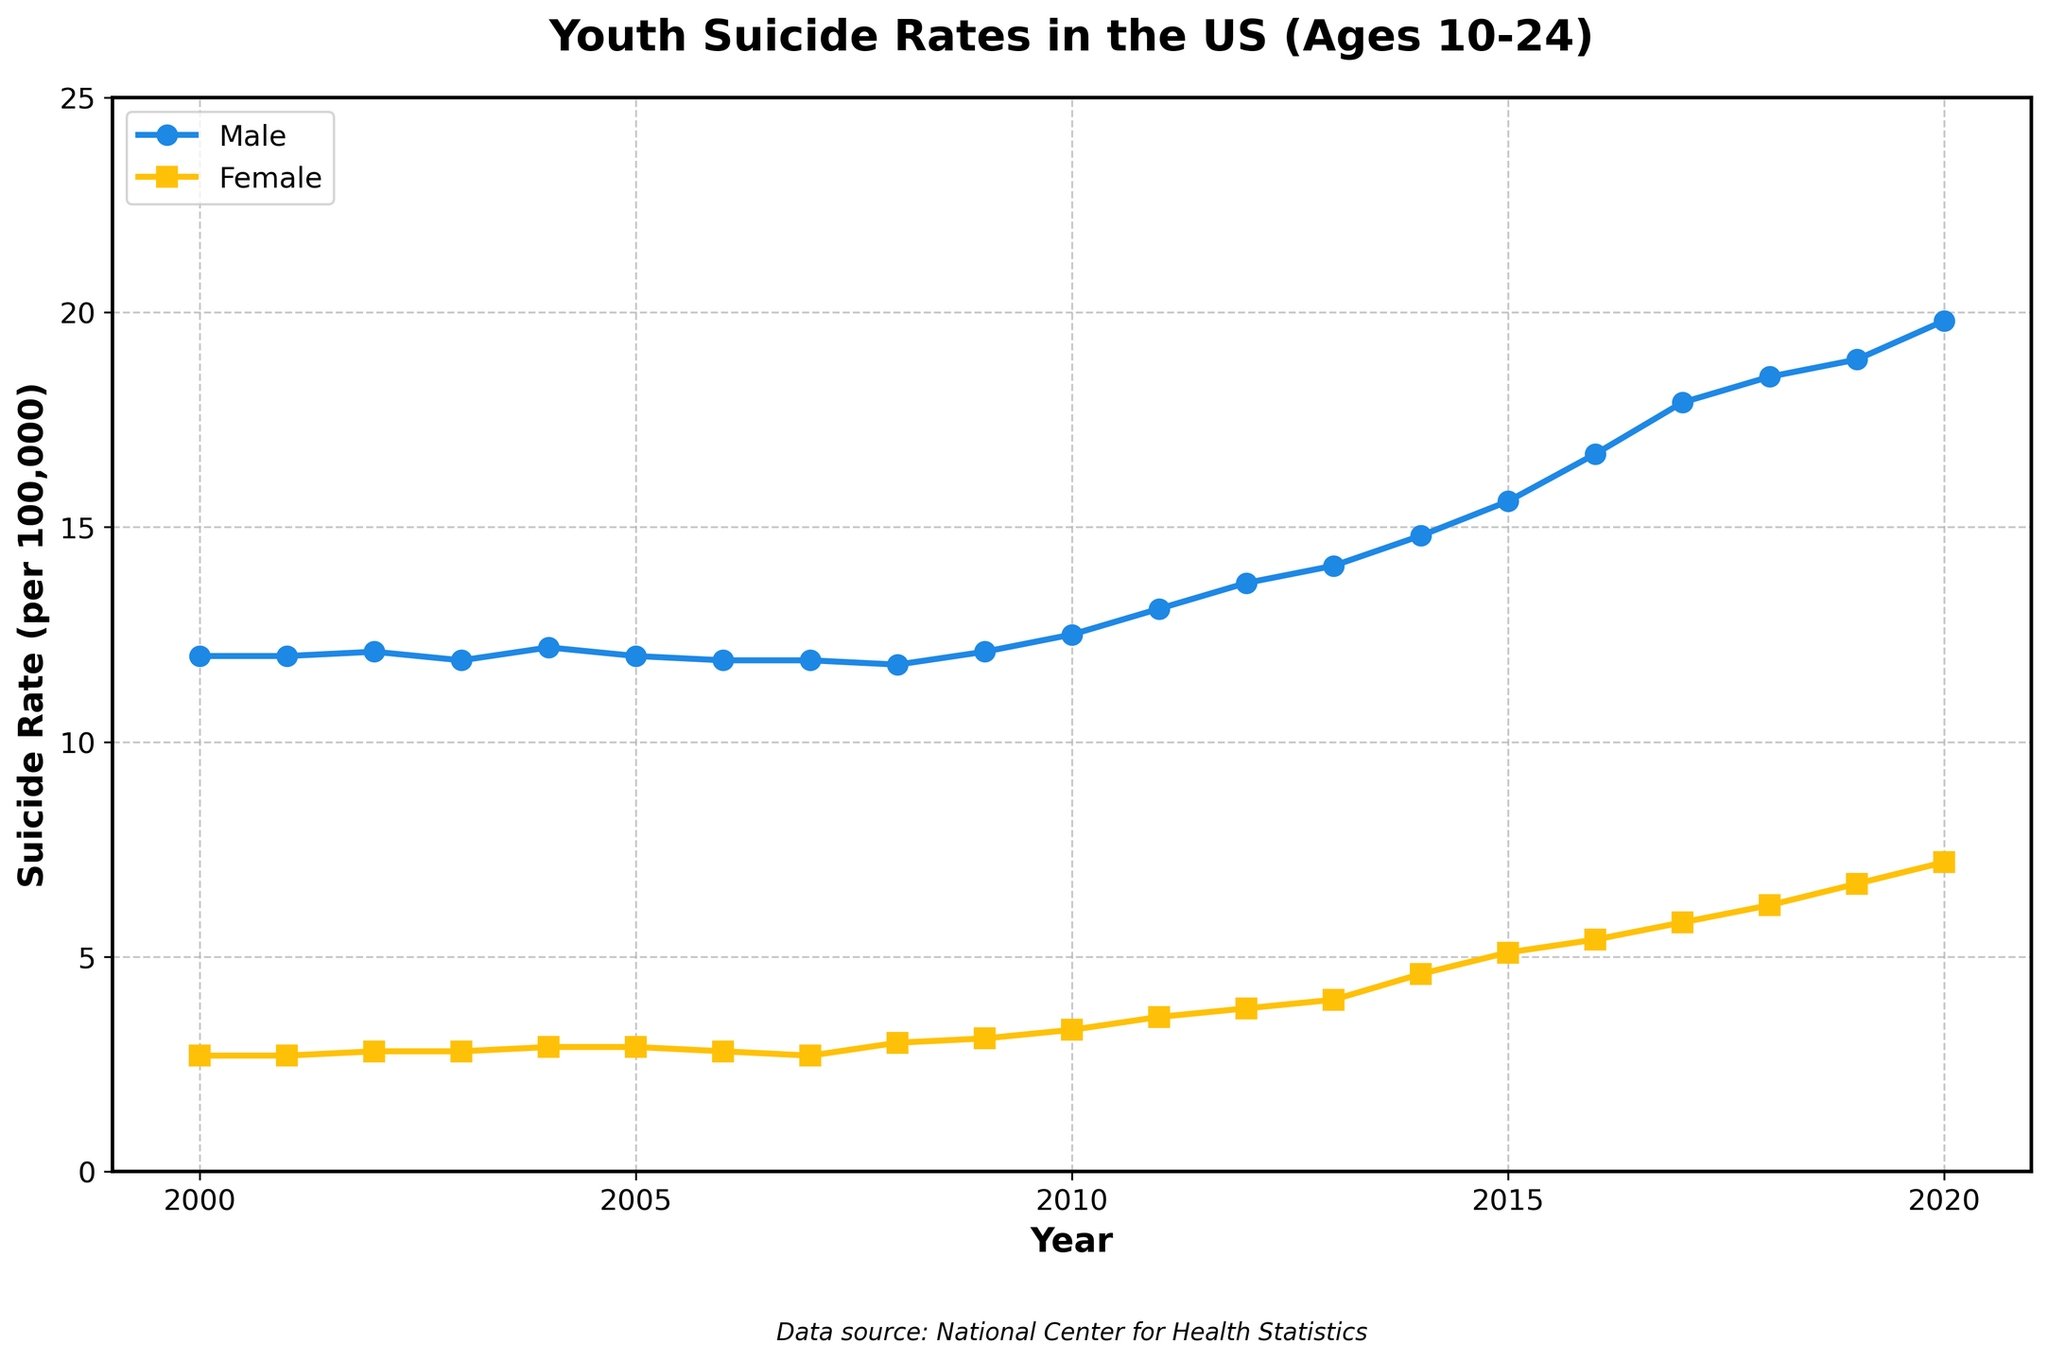What was the suicide rate for males in 2010? In the plot, follow the x-axis to 2010 and find the corresponding point on the male line, which shows the y-axis value for that year.
Answer: 12.5 What is the difference in the suicide rate between males and females in 2020? Look at the y-axis values for both males and females in the year 2020, then subtract the female rate from the male rate.
Answer: 12.6 In which year did females experience a more significant increase compared to the previous year? Analyze the slope of the female line year-by-year and identify which year-to-year change is the steepest.
Answer: 2009 to 2010 How does the general trend of male suicide rates compare to the trend for female suicide rates over the 20-year period? Observe the overall direction and slope of both the male and female lines from 2000 to 2020. Both show an upward trend, but the rate of increase for males is more pronounced.
Answer: Males show a steeper upward trend By how many rates did the female suicide rate increase from 2008 to 2020? Find the y-axis values for females in 2008 and 2020, then subtract the 2008 value from the 2020 value.
Answer: 4.2 Which gender had a higher suicide rate in 2014, and by how much? Locate the points for males and females in 2014, and compare the y-axis values to find the difference.
Answer: Males, by 10.2 What is the trend of suicide rates for males between 2000 and 2003? Trace the male line from 2000 to 2003 to describe the trend. It starts at 12.0, slightly increases, and then decreases to 11.9 in 2003.
Answer: Slight downward trend In which year did both males and females show a rate of increase? Compare both lines year-by-year to find a year where both lines show an upward trend compared to the previous year. Both lines increase from 2009 to 2010.
Answer: 2010 What can you infer about the suicide rates for females between 2016 and 2020? Observe the slope of the female line between 2016 and 2020, which shows a steady upward trend.
Answer: Increasing trend In which year did the male suicide rate reach its peak, and what was the rate? Identify the highest point on the male line and note its x-axis (year) and corresponding y-axis (rate) values.
Answer: 2020, 19.8 